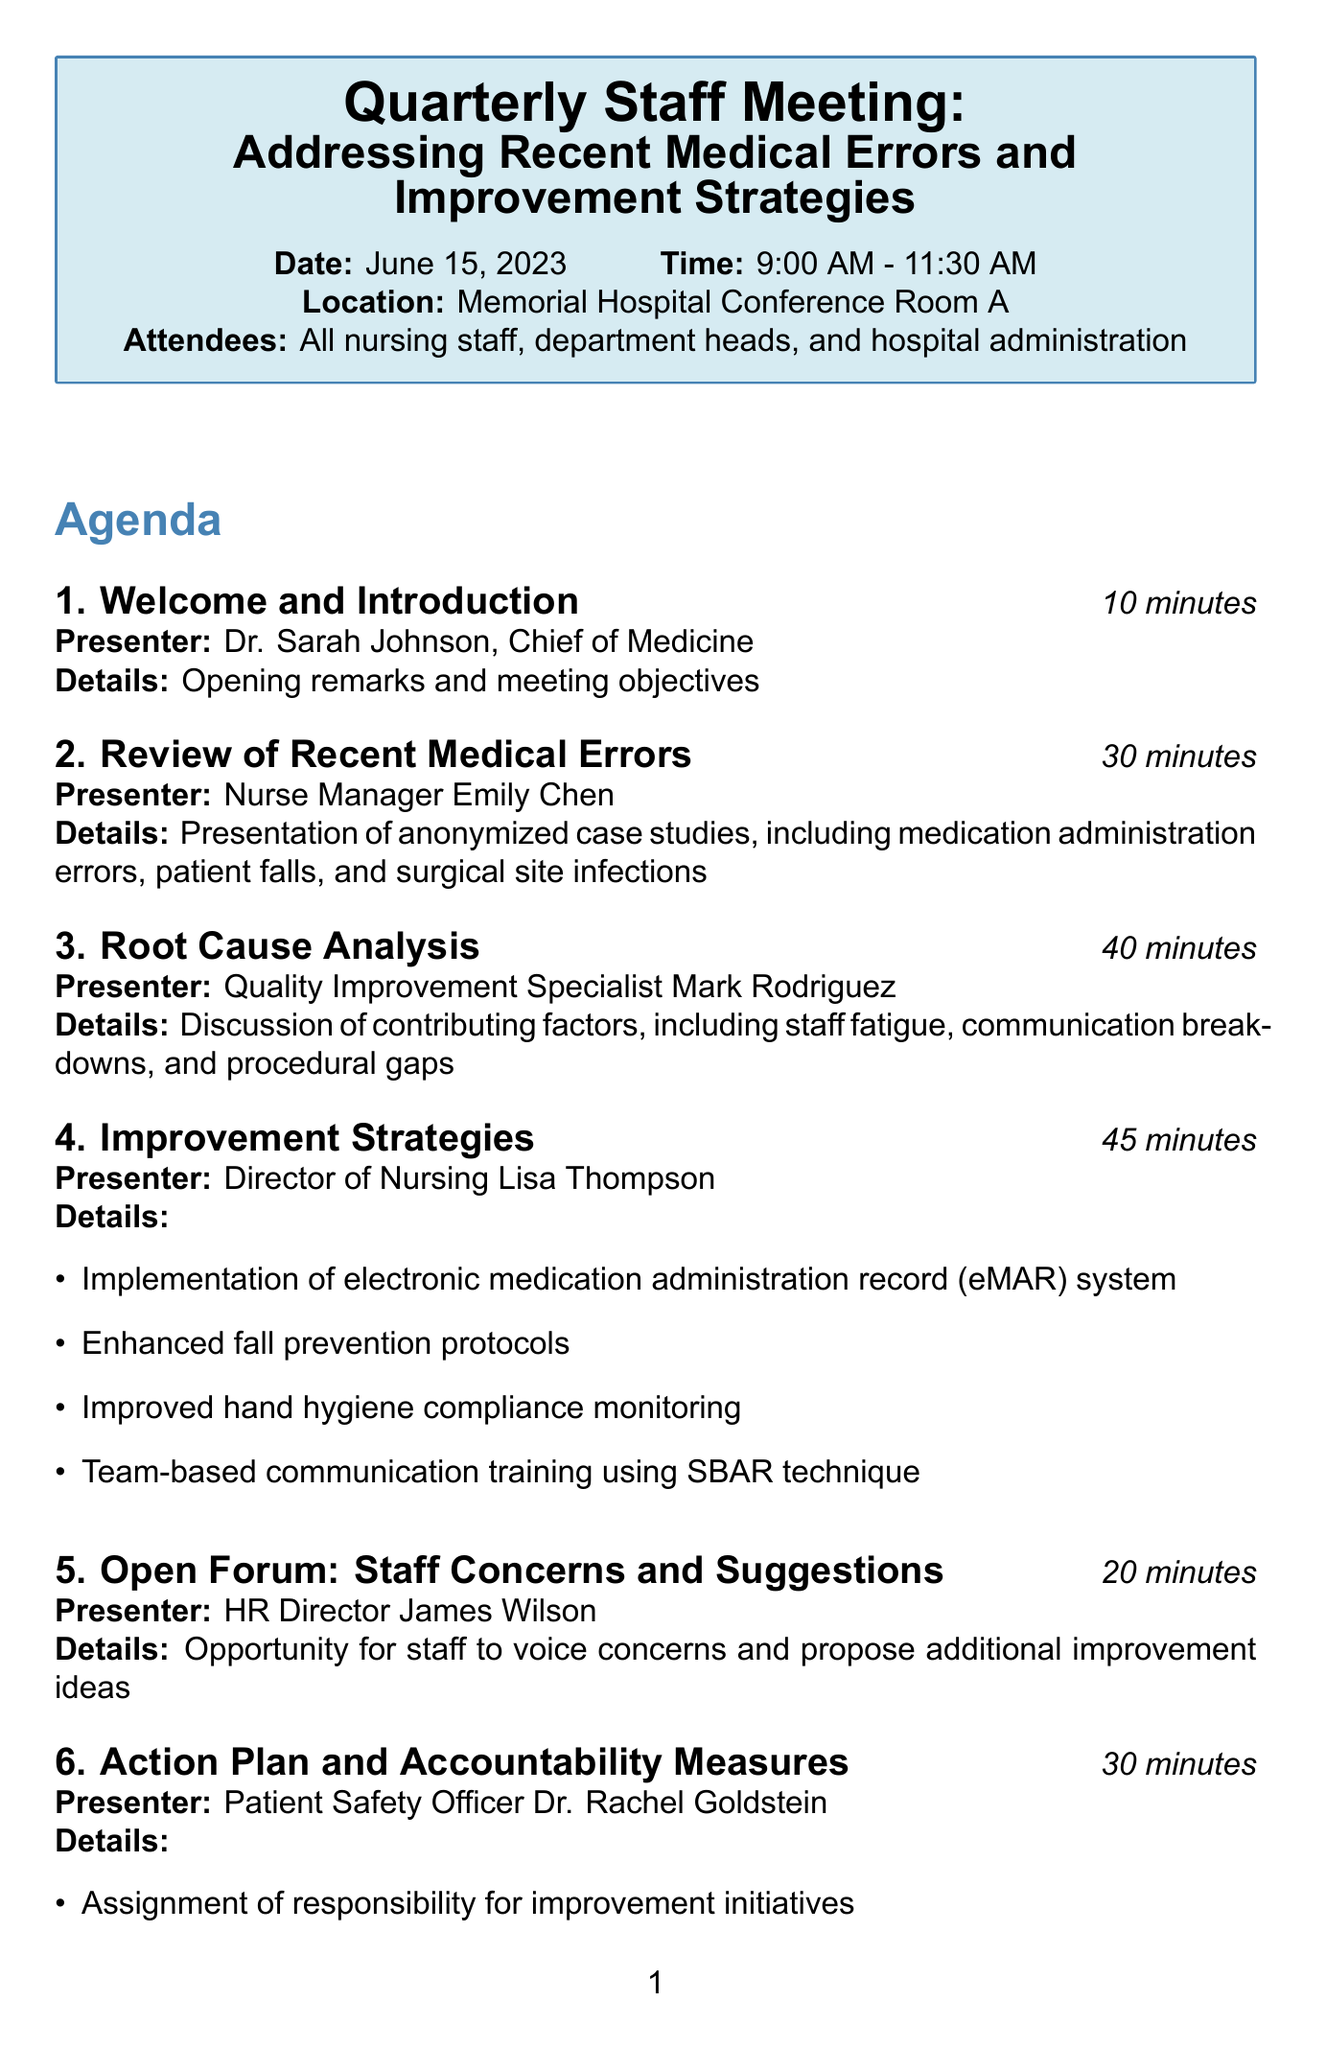What is the date of the meeting? The date of the meeting is explicitly mentioned in the document as June 15, 2023.
Answer: June 15, 2023 Who is presenting the review of recent medical errors? The presenter for this section is specifically listed as Nurse Manager Emily Chen in the agenda.
Answer: Nurse Manager Emily Chen How long is allocated for the discussion on improvement strategies? The duration for improvement strategies is specified in the agenda, indicating a 45-minute session.
Answer: 45 minutes What is the focus of the open forum section? The document states that this section provides an opportunity for staff to voice concerns and propose improvement ideas.
Answer: Staff concerns and suggestions What will be distributed within 48 hours after the meeting? The follow-up actions mentioned indicate that meeting minutes and action items will be distributed within 48 hours.
Answer: Meeting minutes and action items How many attendees are expected at the meeting? The document states that all nursing staff, department heads, and hospital administration are the expected attendees, but does not specify a number.
Answer: All nursing staff, department heads, and hospital administration What is one of the components of the action plan? The action plan includes specifications for the assignment of responsibility for improvement initiatives.
Answer: Assignment of responsibility for improvement initiatives What is the closing emphasis of the CEO during the meeting? The document notes that the closing remarks emphasize a cultural shift towards transparency and continuous improvement.
Answer: Cultural shift towards transparency and continuous improvement 